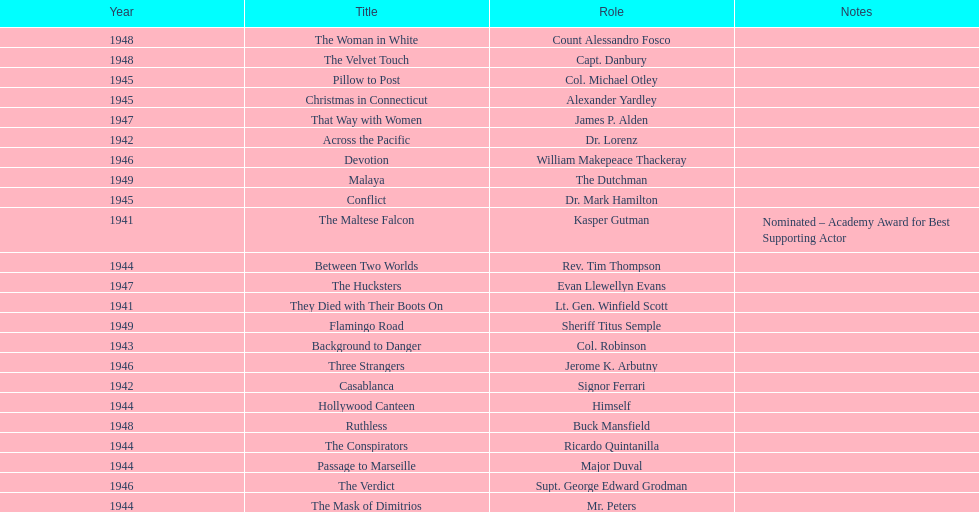What are the movies? The Maltese Falcon, They Died with Their Boots On, Across the Pacific, Casablanca, Background to Danger, Passage to Marseille, Between Two Worlds, The Mask of Dimitrios, The Conspirators, Hollywood Canteen, Pillow to Post, Conflict, Christmas in Connecticut, Three Strangers, Devotion, The Verdict, That Way with Women, The Hucksters, The Velvet Touch, Ruthless, The Woman in White, Flamingo Road, Malaya. Of these, for which did he get nominated for an oscar? The Maltese Falcon. 